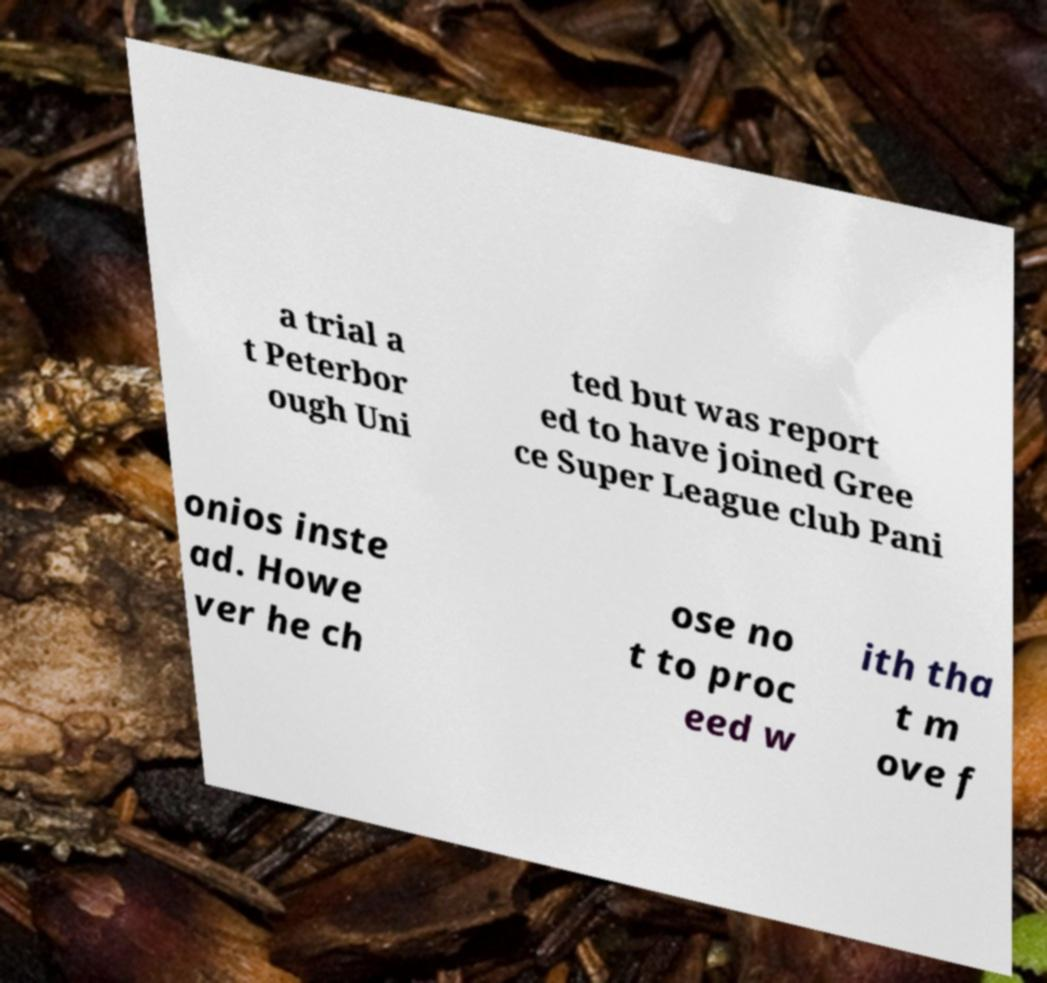Can you read and provide the text displayed in the image?This photo seems to have some interesting text. Can you extract and type it out for me? a trial a t Peterbor ough Uni ted but was report ed to have joined Gree ce Super League club Pani onios inste ad. Howe ver he ch ose no t to proc eed w ith tha t m ove f 